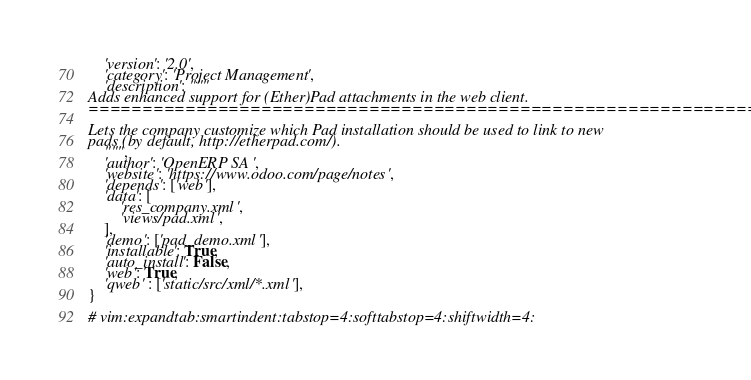<code> <loc_0><loc_0><loc_500><loc_500><_Python_>    'version': '2.0',
    'category': 'Project Management',
    'description': """
Adds enhanced support for (Ether)Pad attachments in the web client.
===================================================================

Lets the company customize which Pad installation should be used to link to new
pads (by default, http://etherpad.com/).
    """,
    'author': 'OpenERP SA',
    'website': 'https://www.odoo.com/page/notes',
    'depends': ['web'],
    'data': [
        'res_company.xml',
        'views/pad.xml',
    ],
    'demo': ['pad_demo.xml'],
    'installable': True,
    'auto_install': False,
    'web': True,
    'qweb' : ['static/src/xml/*.xml'],
}

# vim:expandtab:smartindent:tabstop=4:softtabstop=4:shiftwidth=4:
</code> 